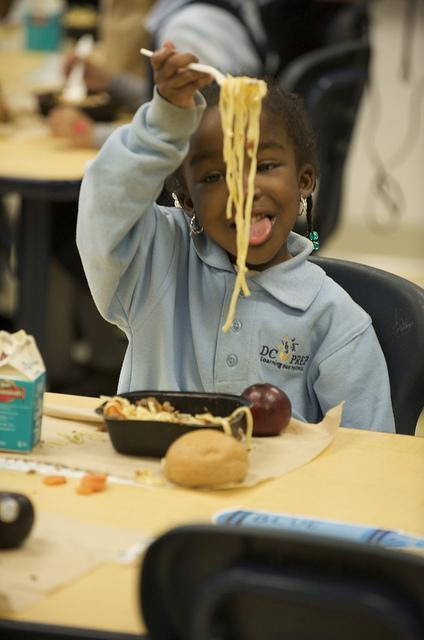How many people are in the picture?
Give a very brief answer. 2. How many chairs are there?
Give a very brief answer. 3. How many dining tables are there?
Give a very brief answer. 2. How many blue drinking cups are in the picture?
Give a very brief answer. 0. 